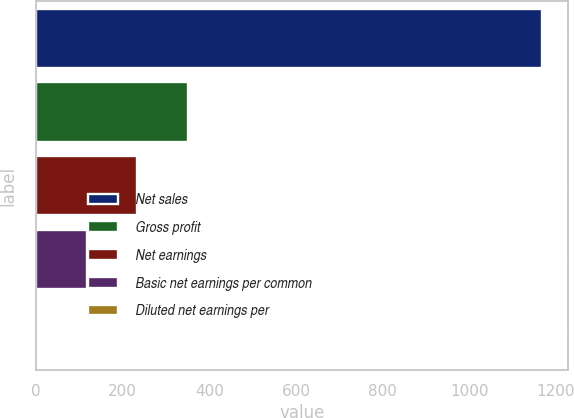Convert chart. <chart><loc_0><loc_0><loc_500><loc_500><bar_chart><fcel>Net sales<fcel>Gross profit<fcel>Net earnings<fcel>Basic net earnings per common<fcel>Diluted net earnings per<nl><fcel>1168.3<fcel>350.66<fcel>233.86<fcel>117.06<fcel>0.26<nl></chart> 